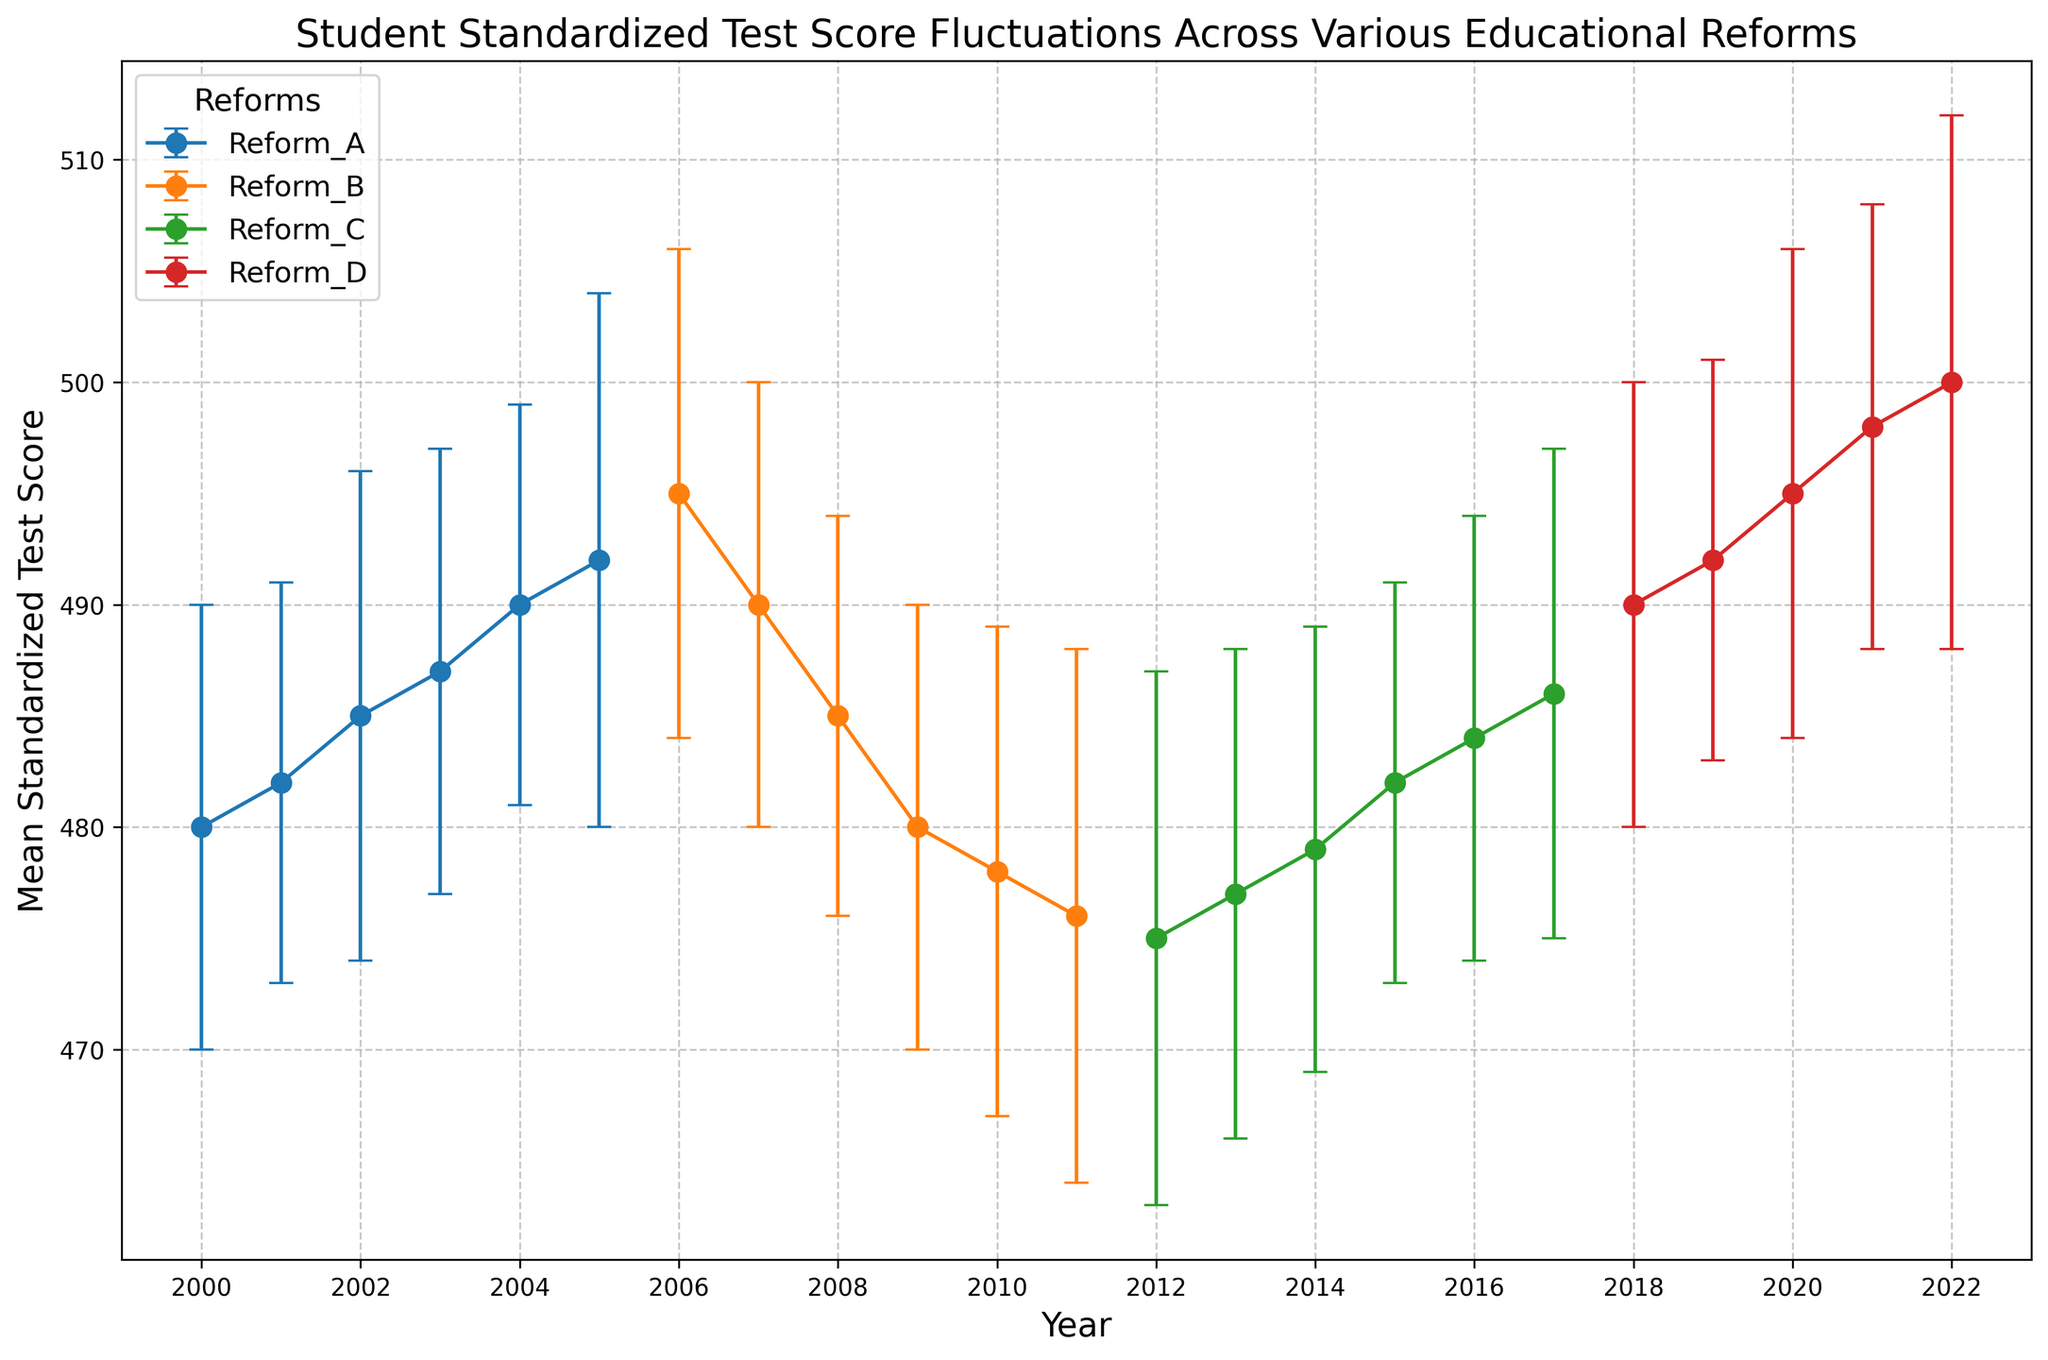What reform period shows the highest mean standardized test scores? By examining the plotted lines along the y-axis, we can see that Reform D period (2018-2022) has the highest mean standardized test scores, ending at 500 in 2022.
Answer: Reform D How did mean scores change during Reform B? Observing the plotted points, the mean scores during Reform B period (2006-2011) started at 495 in 2006 and dropped to 476 in 2011, showing an overall decrease.
Answer: Decreased Which reform period had the most consistent mean scores? Consistency can be inferred from the error bars’ sizes; the smallest error bars indicate less fluctuation. Reform A (2000-2005) has relatively smaller and consistent error bars compared to other reforms.
Answer: Reform A Between which years did the mean scores decrease the most within a single reform period? By comparing drops within each reform, the largest drop is seen in Reform B from 495 in 2006 to 490 in 2007, a decrease of 5 points.
Answer: 2006-2007 What is the overall trend in mean scores across all reforms from 2000 to 2022? Observing the general trajectory of the lines, there is an initial increase during Reform A, a decline during Reform B, another slight increase during Reform C, and a significant increase during Reform D by 2022.
Answer: Increasing trend Between 2009 and 2011, how did the mean test scores change? Checking the data points for these years, the mean score decreases from 480 in 2009 to 476 in 2011, showing a decrease during that period.
Answer: Decreased What was the approximate mean score in 2015? Looking at the year 2015 on the x-axis, the plotted point for Reform C shows a mean score of approximately 482.
Answer: 482 Do any reform periods exhibit an overall upward trend, and if so, which ones? Examining the lines, Reform D (2018-2022) shows a consistent upward trend in mean score values.
Answer: Reform D How does the mean score for Reform C at its peak compare to the mean score at the start of Reform D? Reform C's peak mean score is 486 in 2017, while Reform D starts at 490 in 2018. The start of Reform D is higher than Reform C's peak.
Answer: Reform D is higher During Reform A, what is the range of the mean test scores? The range can be calculated from the minimum and maximum mean scores within Reform A. It starts at 480 in 2000 and ends at 492 in 2005. The range is 492 - 480 = 12.
Answer: 12 